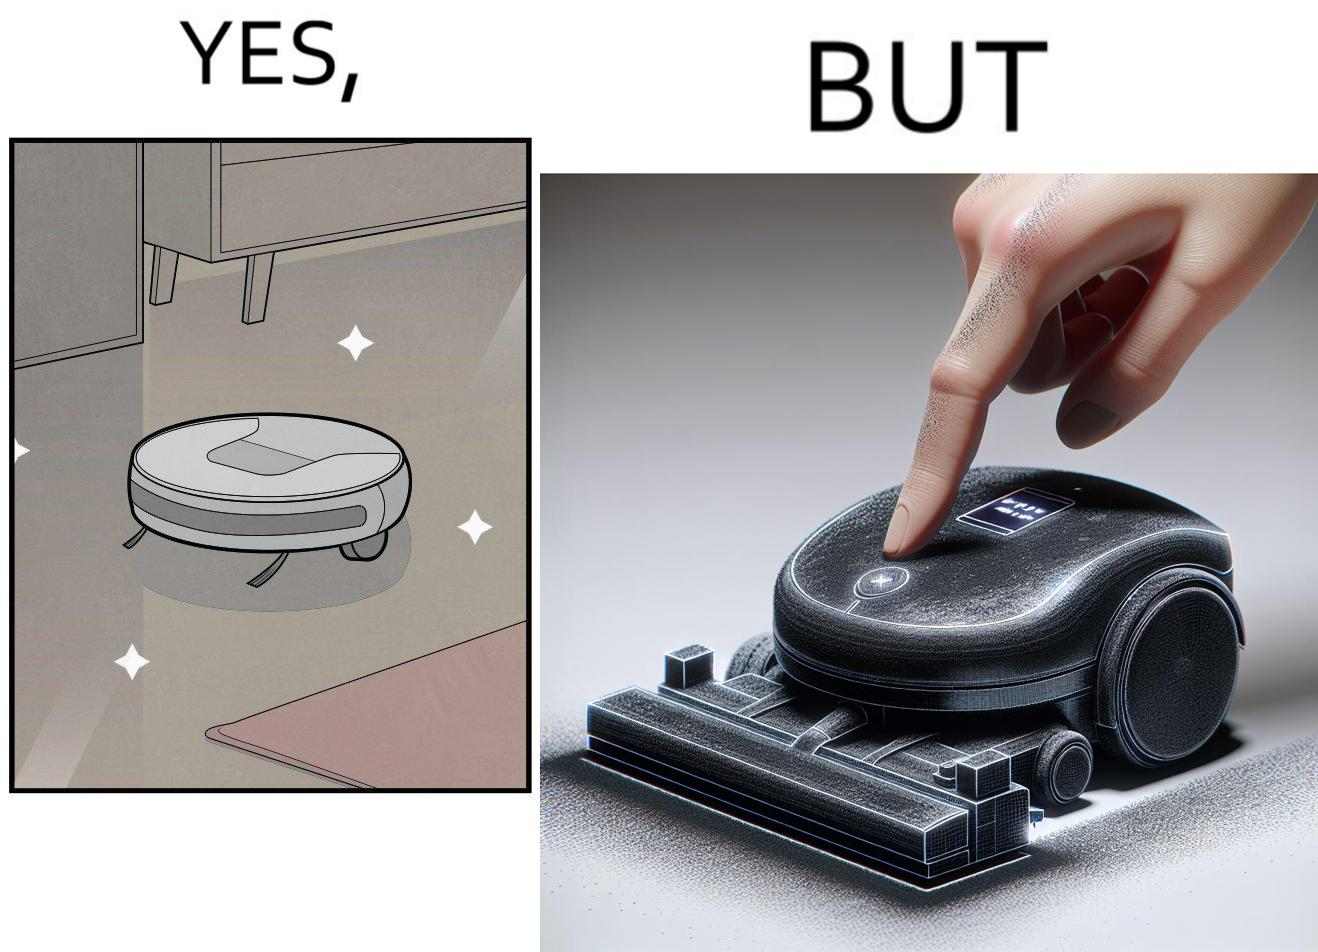What do you see in each half of this image? In the left part of the image: A vacuum cleaning machine that goes around the floor on its own and cleans the floor. Everything  around it looks squeaky clean, and is shining. In the right part of the image: Close up of a vacuum cleaning machine that goes around the floor on its own and cleans the floor. Everything  around it looks squeaky clean, and is shining, but it has a lot of dust on it except one line on it that looks clean. A persons fingertip is visible, and it is covered in dust. 